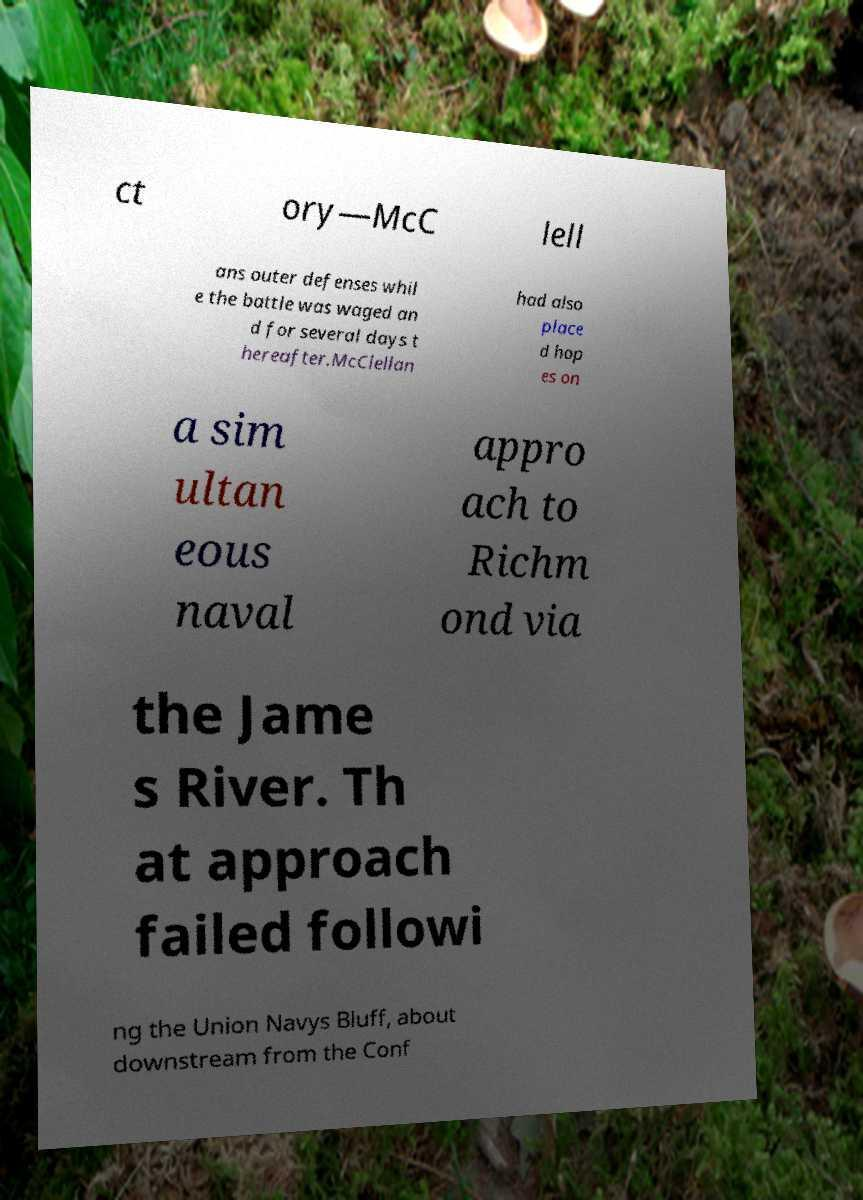For documentation purposes, I need the text within this image transcribed. Could you provide that? ct ory—McC lell ans outer defenses whil e the battle was waged an d for several days t hereafter.McClellan had also place d hop es on a sim ultan eous naval appro ach to Richm ond via the Jame s River. Th at approach failed followi ng the Union Navys Bluff, about downstream from the Conf 